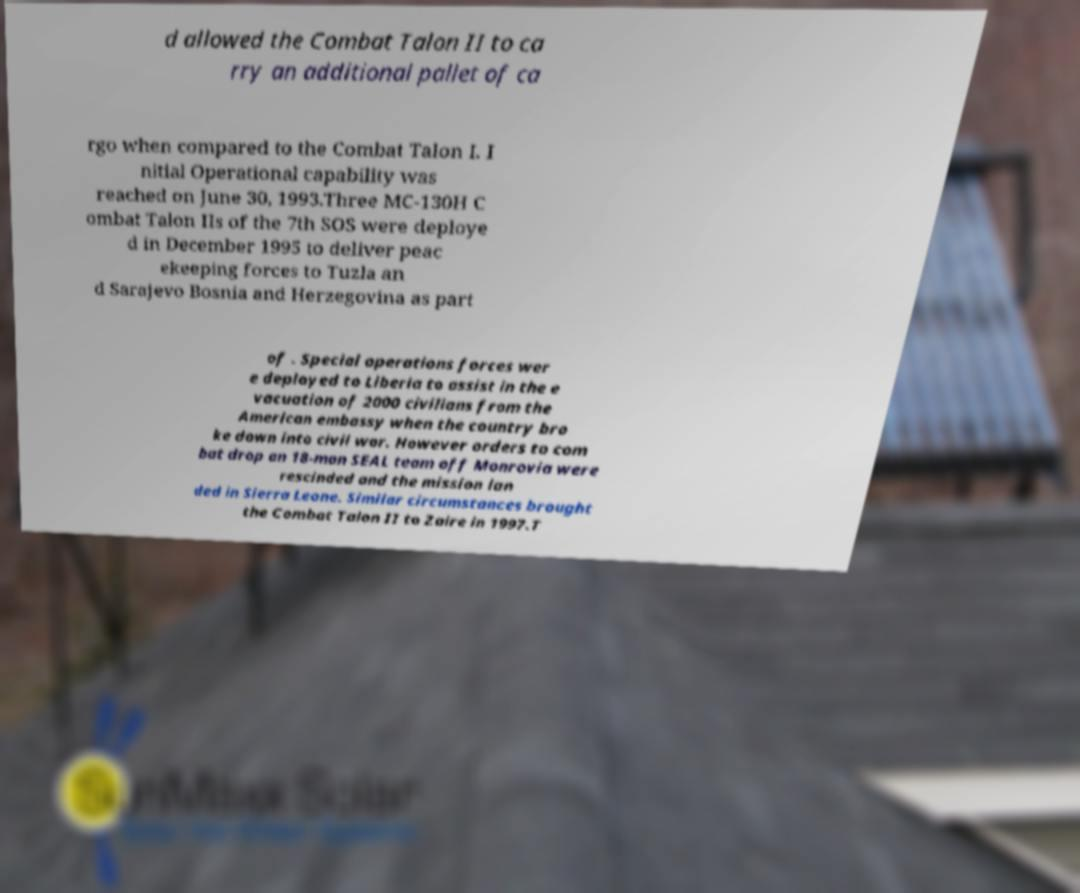What messages or text are displayed in this image? I need them in a readable, typed format. d allowed the Combat Talon II to ca rry an additional pallet of ca rgo when compared to the Combat Talon I. I nitial Operational capability was reached on June 30, 1993.Three MC-130H C ombat Talon IIs of the 7th SOS were deploye d in December 1995 to deliver peac ekeeping forces to Tuzla an d Sarajevo Bosnia and Herzegovina as part of . Special operations forces wer e deployed to Liberia to assist in the e vacuation of 2000 civilians from the American embassy when the country bro ke down into civil war. However orders to com bat drop an 18-man SEAL team off Monrovia were rescinded and the mission lan ded in Sierra Leone. Similar circumstances brought the Combat Talon II to Zaire in 1997.T 